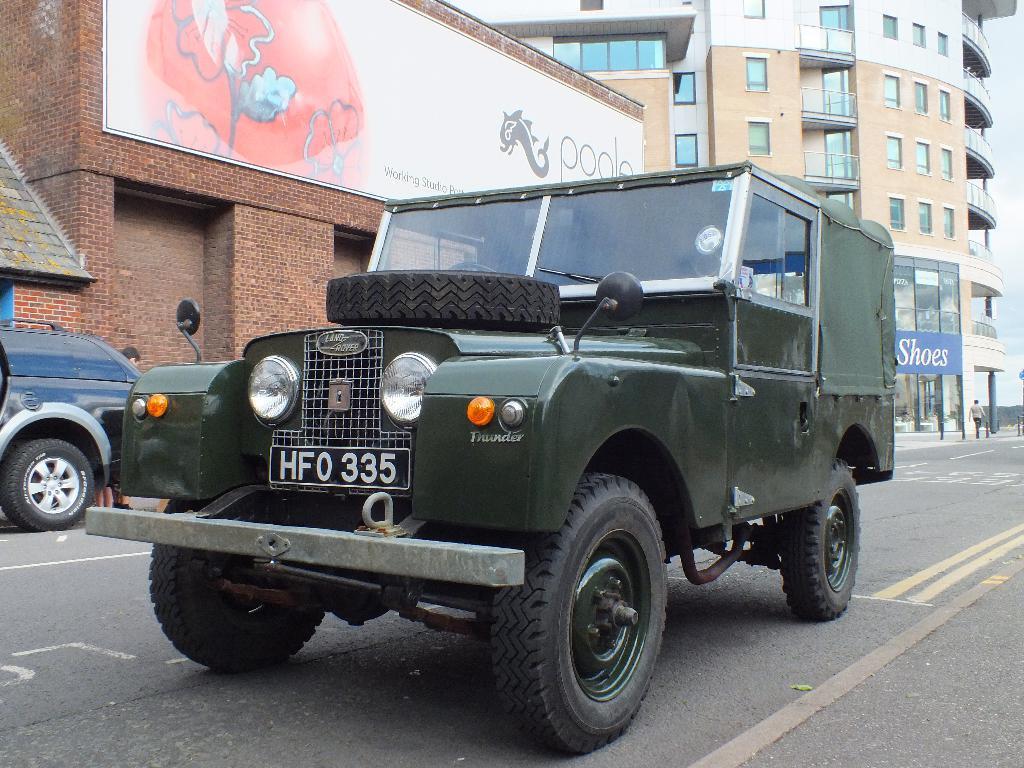Can you describe this image briefly? In this image we can see a jeep on the road, here is the tire, where is the light, here are the buildings, here is the window glass, here is the wall. 